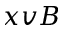Convert formula to latex. <formula><loc_0><loc_0><loc_500><loc_500>x v B</formula> 